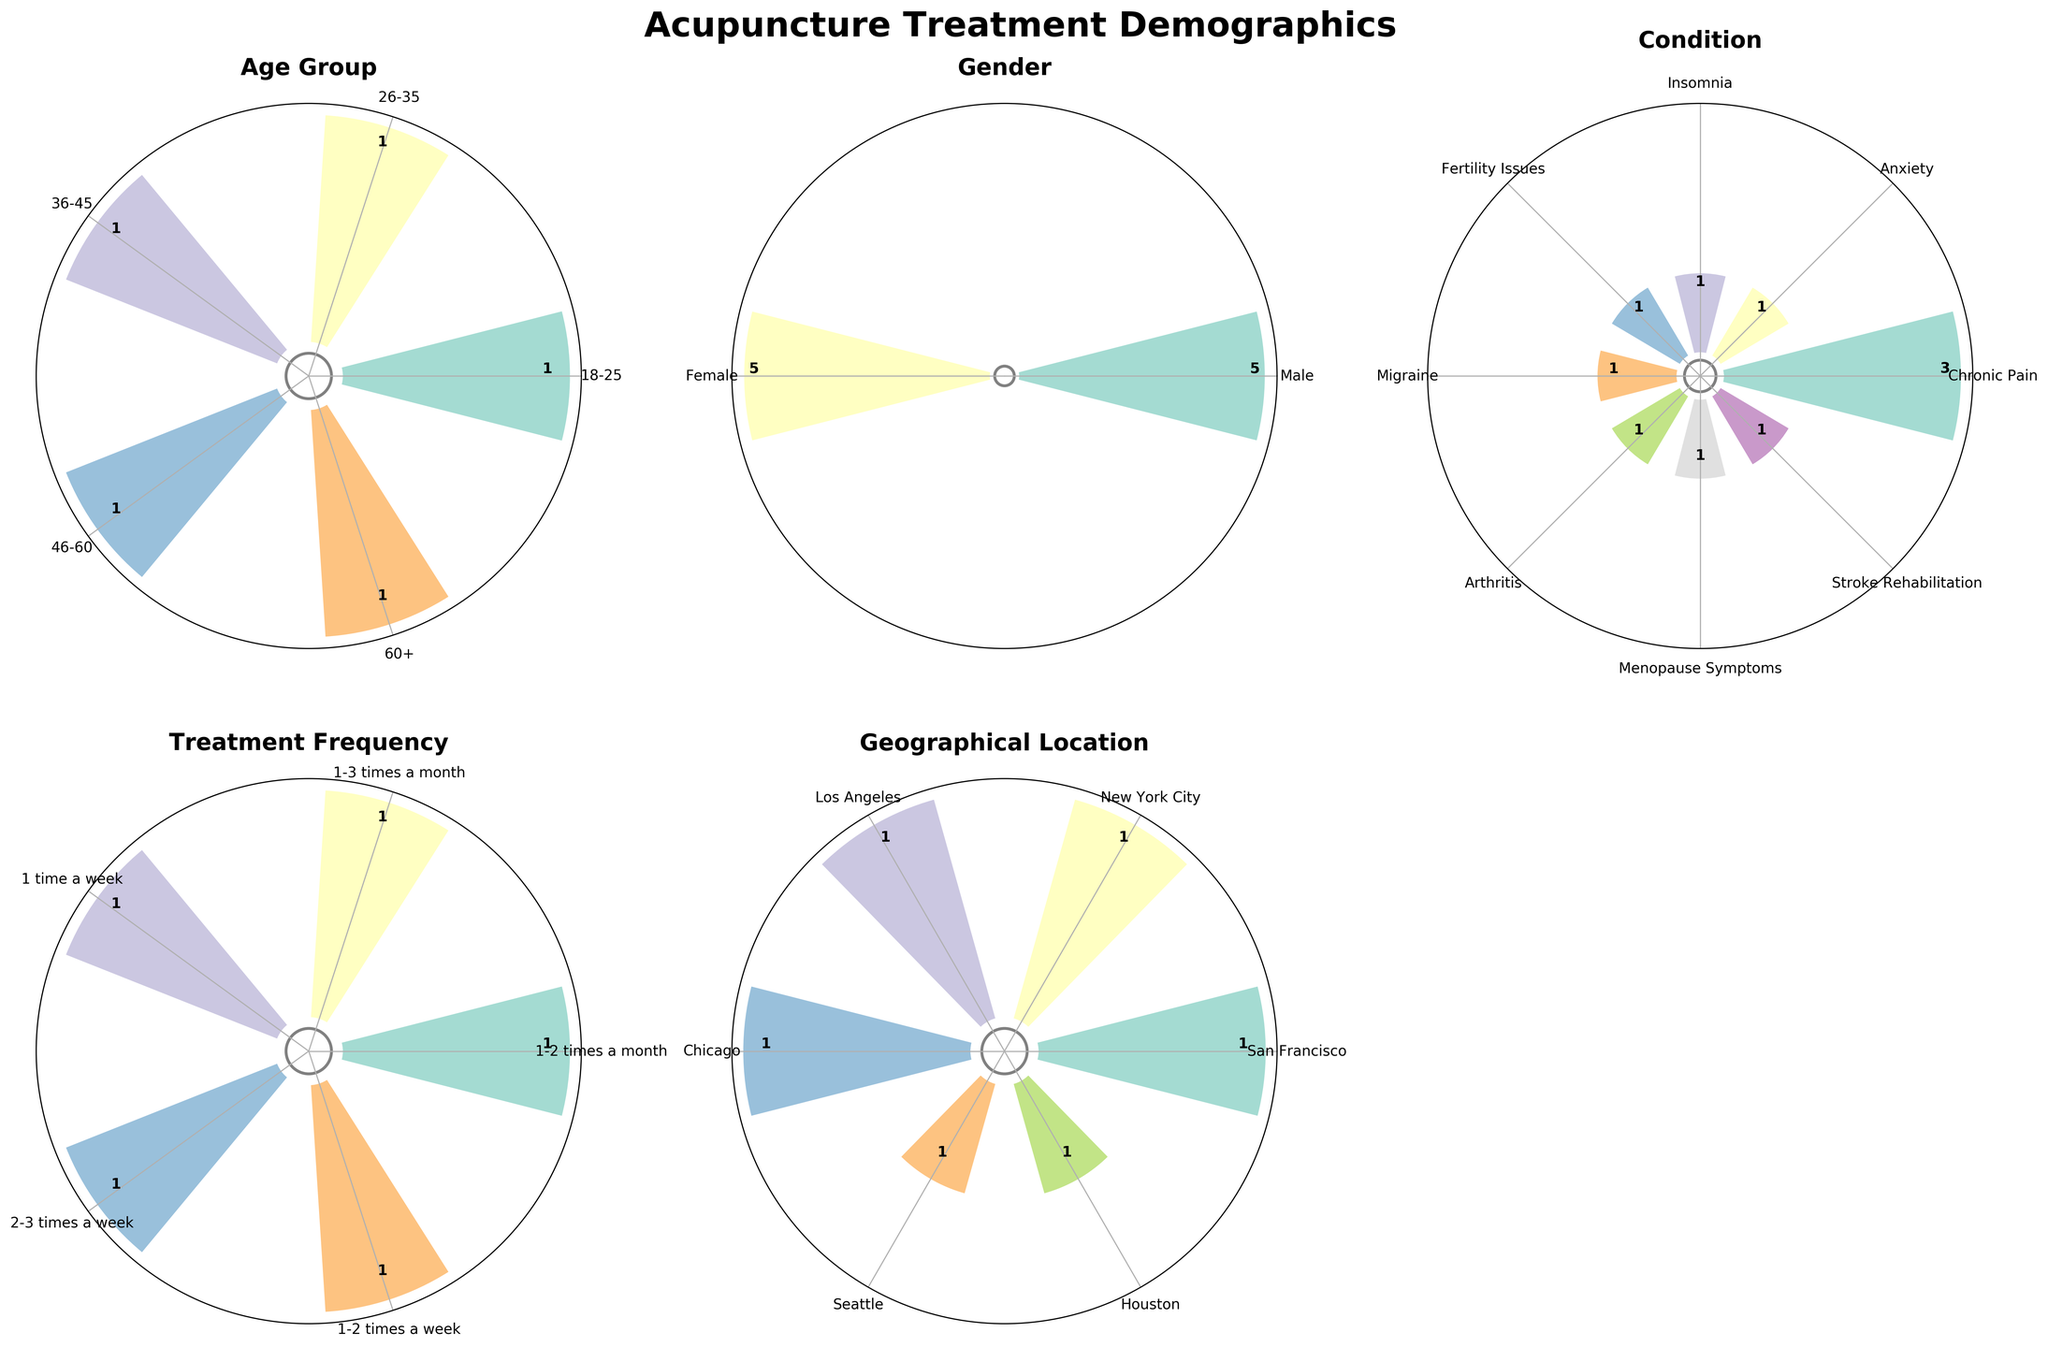what is the title of the figure? The title is usually located at the top of the figure and is intended to give a brief description of what the figure represents. In this case, the title is prominently displayed.
Answer: Acupuncture Treatment Demographics Which group has the largest number of female patients across all demographics? To find this, identify the bar with the highest height in each subplot for the 'Female' category across all subplots.
Answer: Age Group 36-45 (25 patients) How many patients in total are in the age group 18-25? Add the number of male and female patients within the age group 18-25. According to the subplot, there are 15 males and 18 females. 15 + 18 = 33
Answer: 33 Which condition has the least number of patients? Look at the subplot for 'Condition' and identify the bar with the smallest height. According to the figure, the 'Stroke Rehabilitation' bar is the smallest.
Answer: Stroke Rehabilitation How does the number of male patients compare to the number of female patients for the condition 'Chronic Pain'? Check the heights of the 'Chronic Pain' bars for male and female categories in the 'Condition' subplot. According to the figure, Chronic Pain Male is larger than Chronic Pain Female.
Answer: More male patients What geographical location has the highest number of patients receiving acupuncture treatment? In the subplot for 'Geographical Location', identify the bar with the greatest height. According to the figure, Houston has the highest number of patients.
Answer: Houston How many patients undergo treatment 1-2 times a week? Look at the bar lengths in the subplot for 'Treatment Frequency' and sum the heights of the bars for '1-2 times a week'. The bars depict counts for 36-45 Male (22) and 60+ Male (10). So, 22 + 10 = 32
Answer: 32 Which gender has a higher patient count in the 26-35 age group? Look at the subplot for 'Age Group' and compare the bars for male and female in the 26-35 category. According to the figure, the female count bar is higher than the male bar.
Answer: Female What is the average number of patients across all conditions? Sum the number of patients for all conditions and divide by the number of conditions. Chronic Pain (15 + 14), Anxiety (18), Insomnia (12), Fertility Issues (20), Migraine (25), Arthritis (19), Menopause Symptoms (17), Stroke Rehabilitation (10). There are 8 conditions. Avg = (15+14+18+12+20+25+19+17+10)/8 = 150/8 = 18.75
Answer: 18.75 What's the proportion of patients treated in Chicago out of the total patients? First, sum the number of patients in Chicago (20 + 10 = 30), then find the total number of patients (15 + 18 + 12 + 20 + 22 + 25 + 19 + 17 + 10 + 14 = 172). Proportion = 30/172 = 0.174 or 17.4%
Answer: 17.4% 